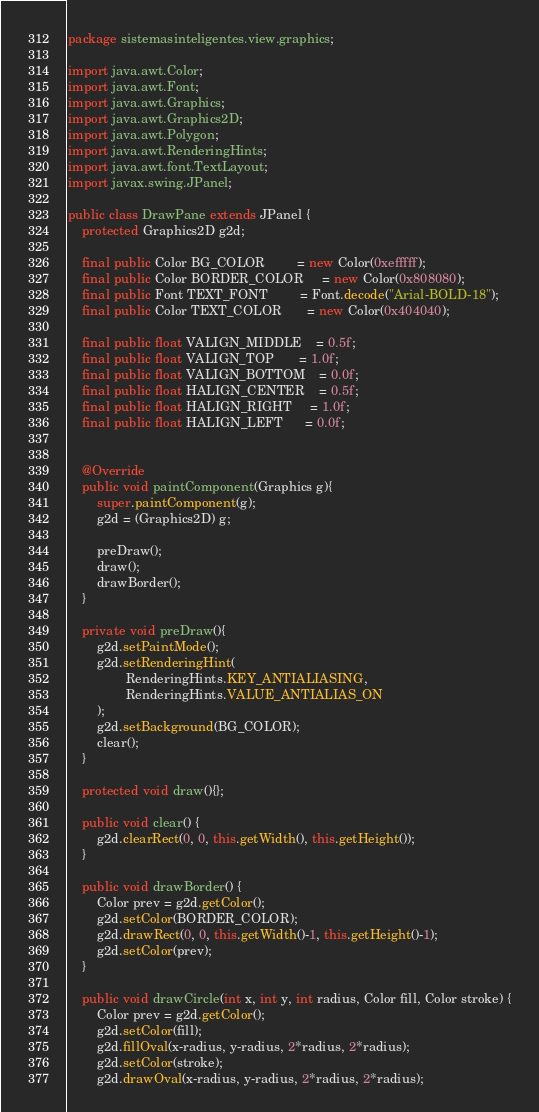Convert code to text. <code><loc_0><loc_0><loc_500><loc_500><_Java_>package sistemasinteligentes.view.graphics;

import java.awt.Color;
import java.awt.Font;
import java.awt.Graphics;
import java.awt.Graphics2D;
import java.awt.Polygon;
import java.awt.RenderingHints;
import java.awt.font.TextLayout;
import javax.swing.JPanel;

public class DrawPane extends JPanel {
    protected Graphics2D g2d;
    
    final public Color BG_COLOR         = new Color(0xefffff);
    final public Color BORDER_COLOR     = new Color(0x808080);    
    final public Font TEXT_FONT         = Font.decode("Arial-BOLD-18");
    final public Color TEXT_COLOR       = new Color(0x404040);    
    
    final public float VALIGN_MIDDLE    = 0.5f;
    final public float VALIGN_TOP       = 1.0f;
    final public float VALIGN_BOTTOM    = 0.0f;
    final public float HALIGN_CENTER    = 0.5f;
    final public float HALIGN_RIGHT     = 1.0f;
    final public float HALIGN_LEFT      = 0.0f;
    

    @Override
    public void paintComponent(Graphics g){
        super.paintComponent(g);
        g2d = (Graphics2D) g;
        
        preDraw();
        draw();
        drawBorder();
    }
    
    private void preDraw(){
        g2d.setPaintMode();
        g2d.setRenderingHint(
                RenderingHints.KEY_ANTIALIASING,
                RenderingHints.VALUE_ANTIALIAS_ON
        );
        g2d.setBackground(BG_COLOR);
        clear();
    }
    
    protected void draw(){};
    
    public void clear() {
        g2d.clearRect(0, 0, this.getWidth(), this.getHeight());
    }
    
    public void drawBorder() {
        Color prev = g2d.getColor();
        g2d.setColor(BORDER_COLOR);
        g2d.drawRect(0, 0, this.getWidth()-1, this.getHeight()-1);
        g2d.setColor(prev);
    }    
    
    public void drawCircle(int x, int y, int radius, Color fill, Color stroke) {
        Color prev = g2d.getColor();
        g2d.setColor(fill);
        g2d.fillOval(x-radius, y-radius, 2*radius, 2*radius);
        g2d.setColor(stroke);
        g2d.drawOval(x-radius, y-radius, 2*radius, 2*radius);</code> 